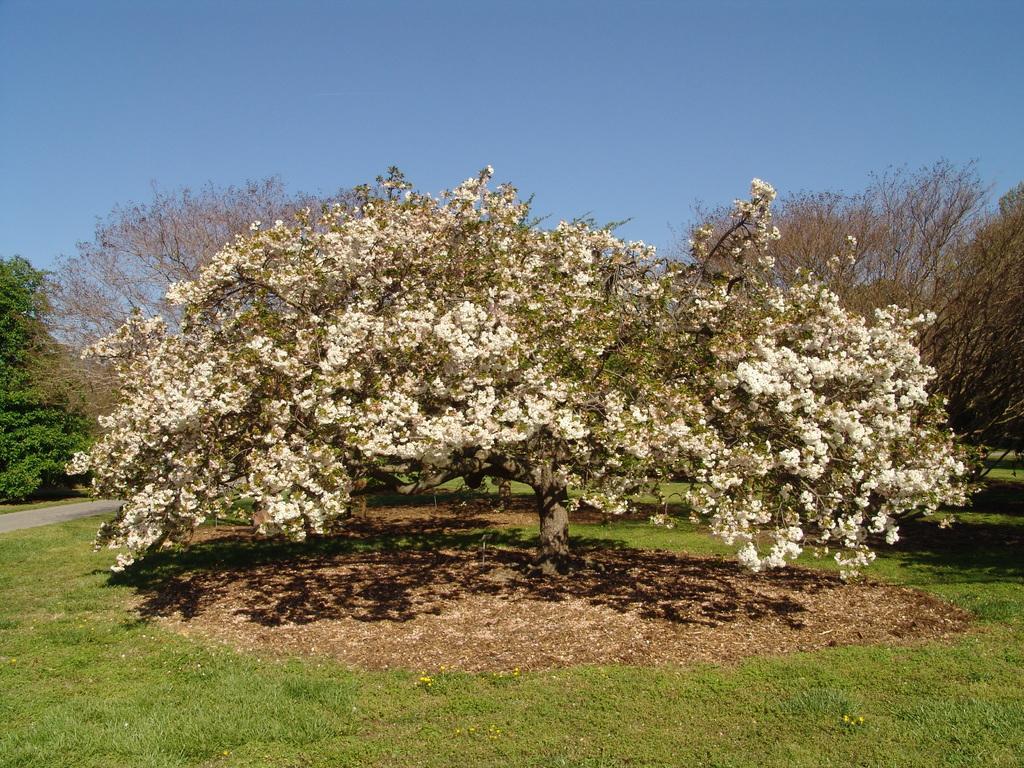Describe this image in one or two sentences. In this image we can see many trees. At the bottom we can see the grass. At the top we can see the sky. 